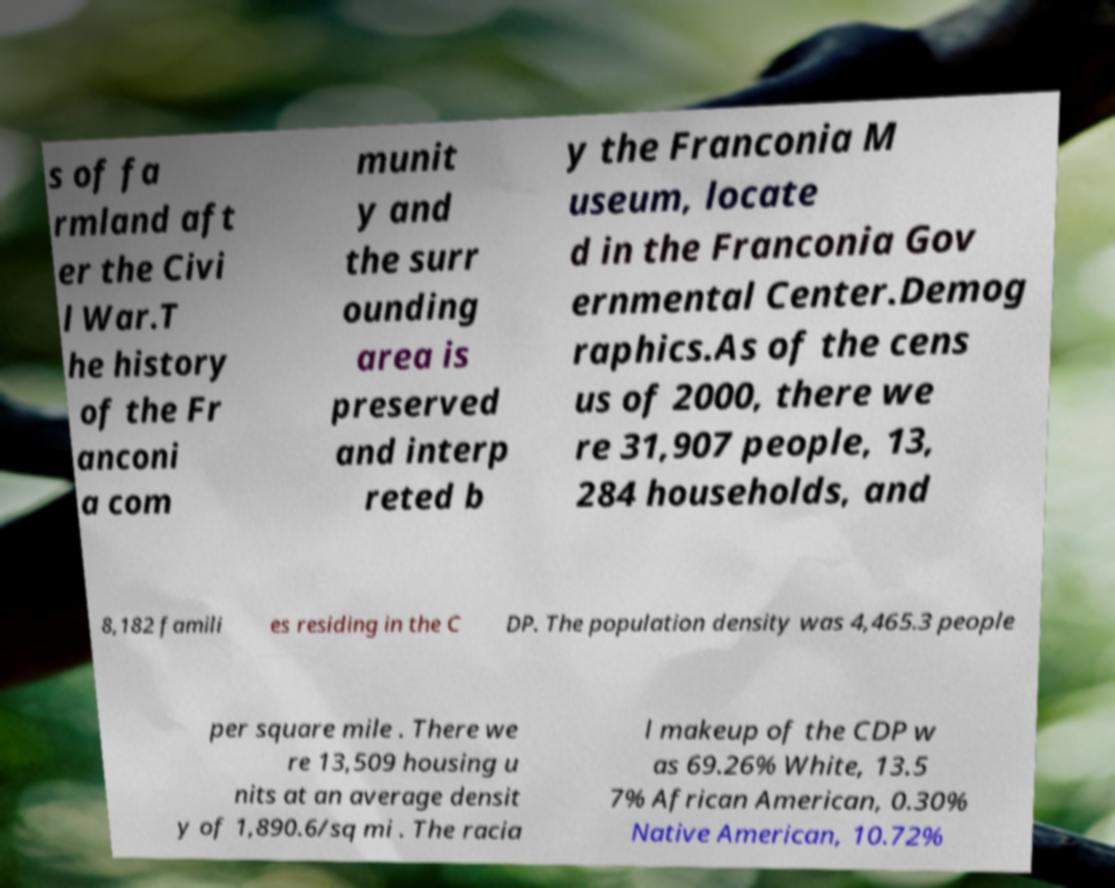Please identify and transcribe the text found in this image. s of fa rmland aft er the Civi l War.T he history of the Fr anconi a com munit y and the surr ounding area is preserved and interp reted b y the Franconia M useum, locate d in the Franconia Gov ernmental Center.Demog raphics.As of the cens us of 2000, there we re 31,907 people, 13, 284 households, and 8,182 famili es residing in the C DP. The population density was 4,465.3 people per square mile . There we re 13,509 housing u nits at an average densit y of 1,890.6/sq mi . The racia l makeup of the CDP w as 69.26% White, 13.5 7% African American, 0.30% Native American, 10.72% 